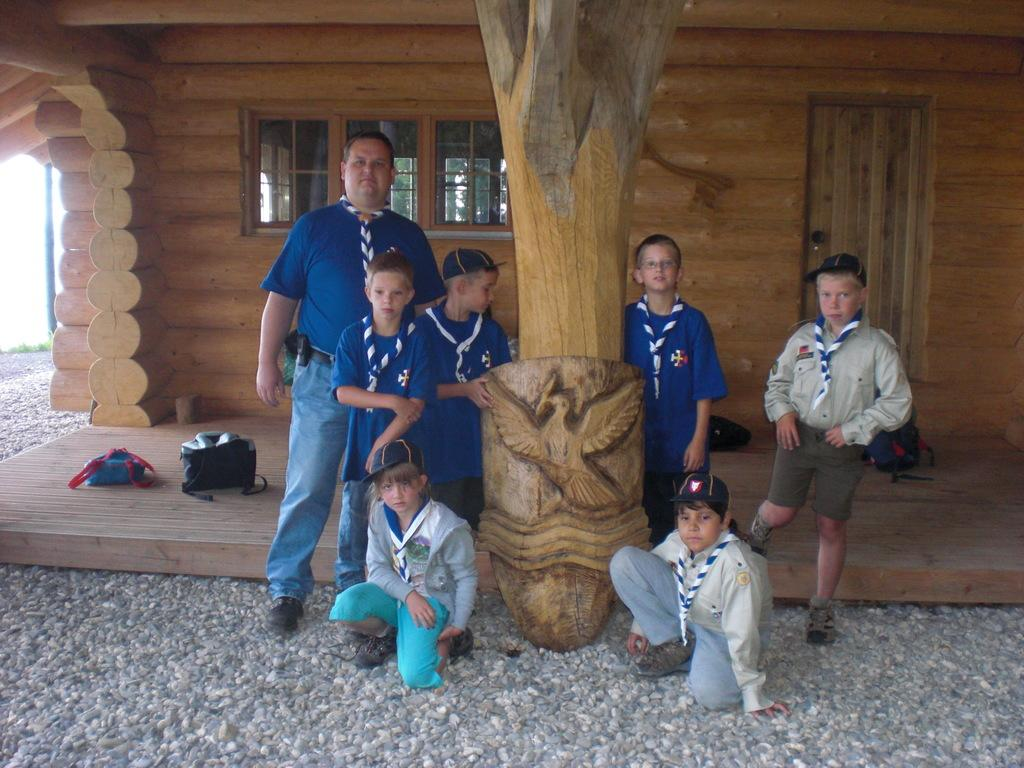How many people are in the image? There is a group of people in the image, but the exact number is not specified. What are some of the people wearing? Some of the people are wearing caps. What type of building is in the image? There is a wooden building in the image. What items can be found on the floor in the image? There are bags on the floor in the image. What type of natural material is present in the image? There are stones in the image. What type of structure is in the image? There is a pole in the image. What architectural features are present in the wooden building? There are windows in the image. What is a possible entrance or exit in the image? There is a door in the image. What type of corn is growing in the image? There is no corn present in the image. What belief system do the people in the image follow? The image does not provide any information about the beliefs or religion of the people in the image. 